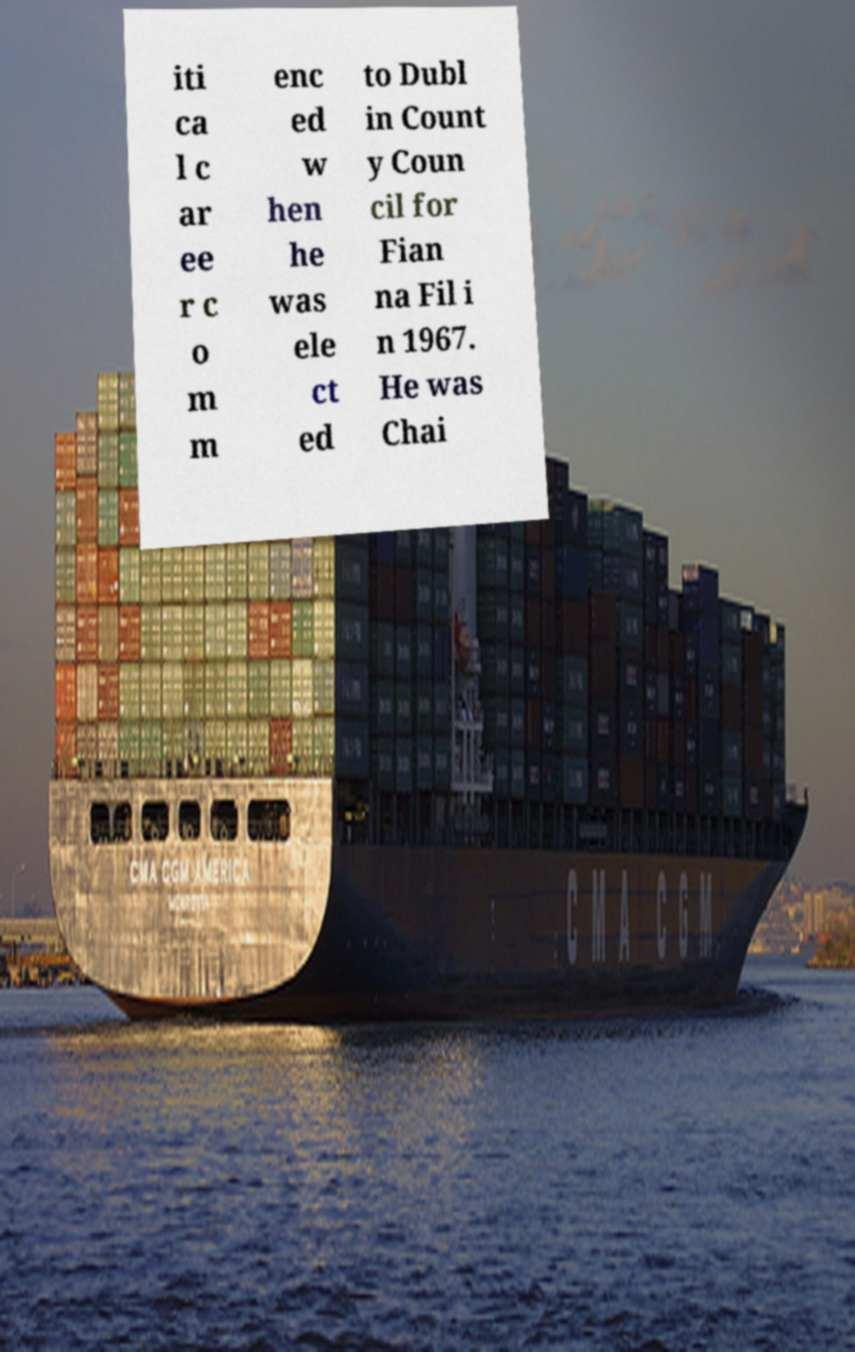Could you assist in decoding the text presented in this image and type it out clearly? iti ca l c ar ee r c o m m enc ed w hen he was ele ct ed to Dubl in Count y Coun cil for Fian na Fil i n 1967. He was Chai 